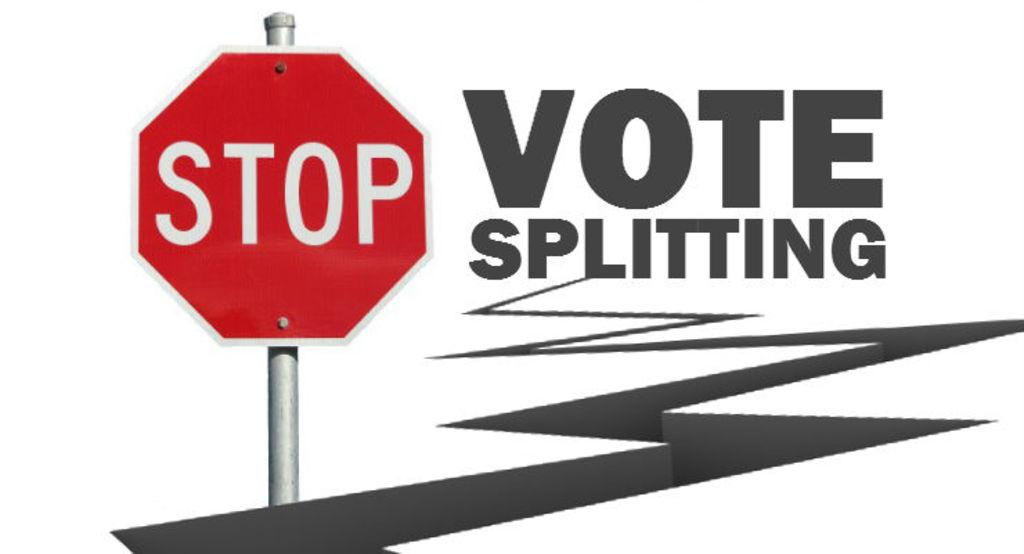<image>
Give a short and clear explanation of the subsequent image. A sign says that we should stop vote splitting. 